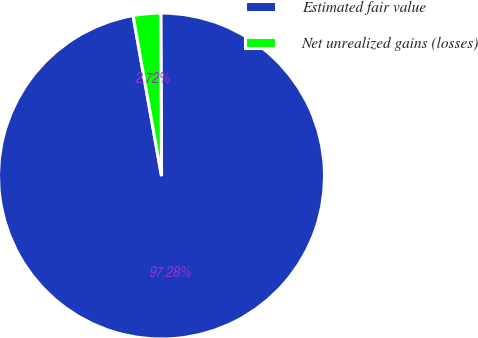Convert chart to OTSL. <chart><loc_0><loc_0><loc_500><loc_500><pie_chart><fcel>Estimated fair value<fcel>Net unrealized gains (losses)<nl><fcel>97.28%<fcel>2.72%<nl></chart> 